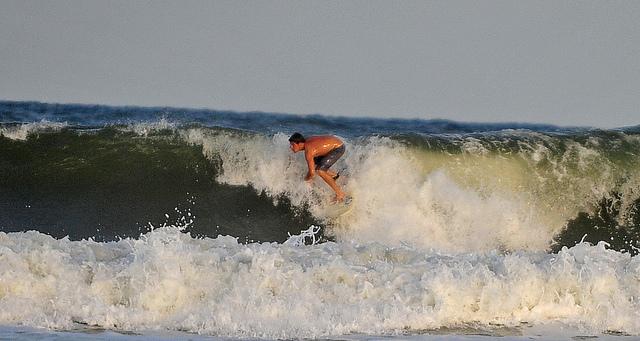What position is the man in?
Be succinct. Crouching. How tall is the wave?
Write a very short answer. 10 feet. Where is the man?
Quick response, please. Ocean. 